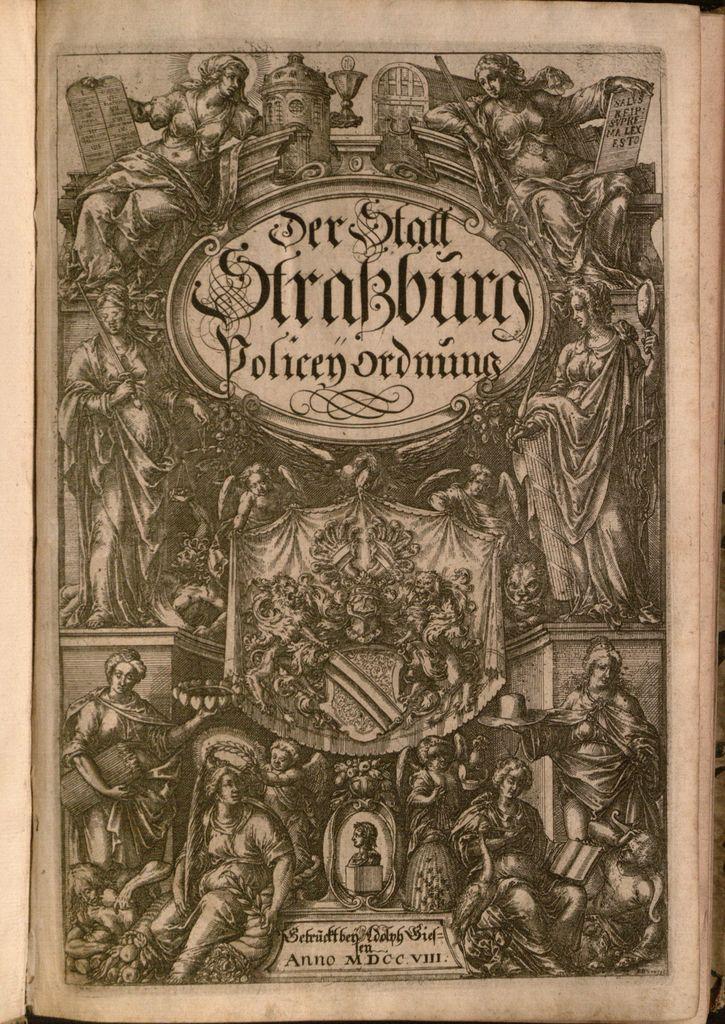What does this say?
Provide a short and direct response. Der staff strakburg. 